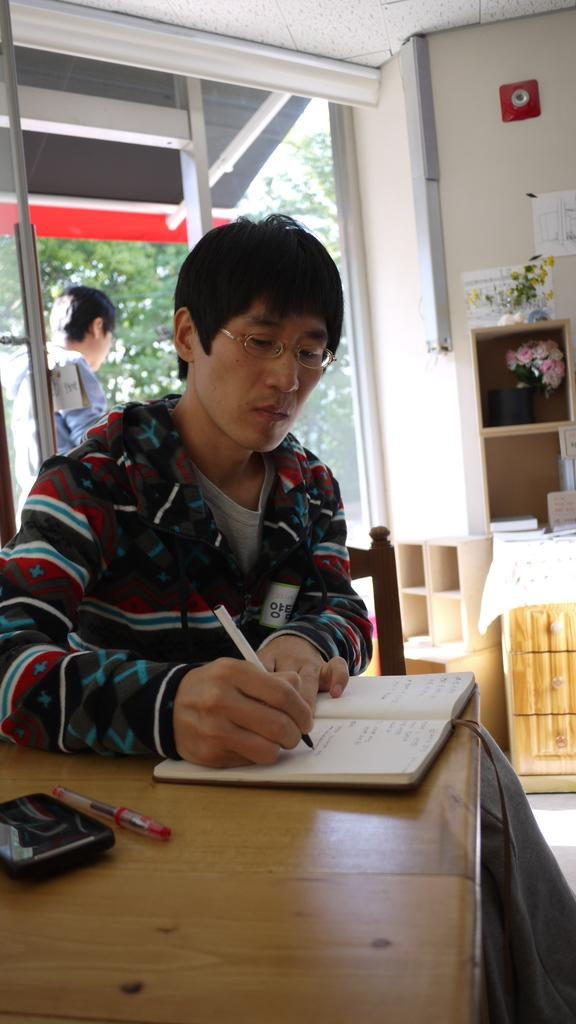How many men are in the image? There are two men in the image. What is one of the men doing? One man is sitting. What is the sitting man doing with the book? The sitting man is writing something in a book. What furniture is present in the image? There is a chair and a table in the image. What writing instrument is visible in the image? There is a red pen in the image. What electronic device is present in the image? There is a device in the image. What month is it in the image? The month cannot be determined from the image, as there is no information about the time or date. What type of truck is parked outside the house in the image? There is no truck or house present in the image. 